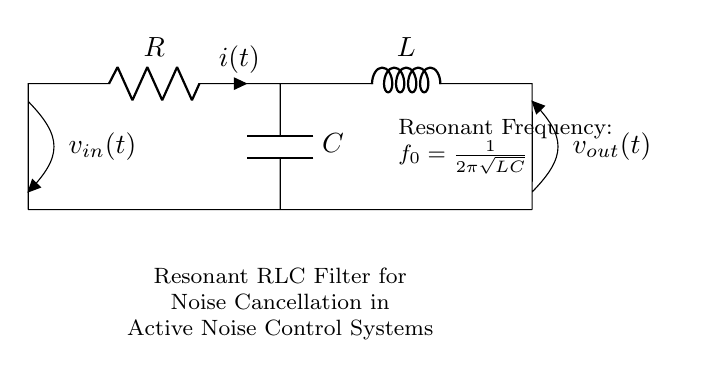What is the name of the circuit? The name of the circuit is indicated in the diagram as "Resonant RLC Filter for Noise Cancellation in Active Noise Control Systems." It is typical to name circuits based on their function or design, which explains its purpose for noise cancellation.
Answer: Resonant RLC Filter for Noise Cancellation in Active Noise Control Systems What are the components present in the circuit? The components in the circuit are a resistor, an inductor, and a capacitor. Their presence is shown as R, L, and C respectively in the circuit diagram, which are standard components in RLC circuits.
Answer: Resistor, Inductor, Capacitor What is the resonant frequency formula? The resonant frequency formula is provided in the circuit diagram as "f_0 = 1/(2π√(LC))." This formula defines the frequency at which the circuit will resonate, which is crucial for noise cancellation applications.
Answer: f_0 = 1/(2π√(LC)) Which component defines the current? The current in the circuit is defined by the resistor, as indicated on the diagram with i(t), which shows the flow of current through it. The resistor's role in the circuit is vital as it helps control the current flow overall.
Answer: Resistor What is the relationship between voltage and inductance in this circuit? The voltage across the inductor is related to the rate of change of current through it. According to Lenz's law, the inductor creates a back emf proportional to the rate of change, which influences the overall circuit behavior and responses during operation.
Answer: Back emf Which component is responsible for phase shift in the circuit? The capacitor is responsible for causing a phase shift between the voltage and the current in the circuit. Capacitors store energy in the form of an electric field and their behavior creates a lead in the circuit's response.
Answer: Capacitor 